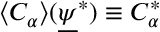Convert formula to latex. <formula><loc_0><loc_0><loc_500><loc_500>\langle C _ { \alpha } \rangle ( \underline { \psi } ^ { * } ) \equiv C _ { \alpha } ^ { * }</formula> 